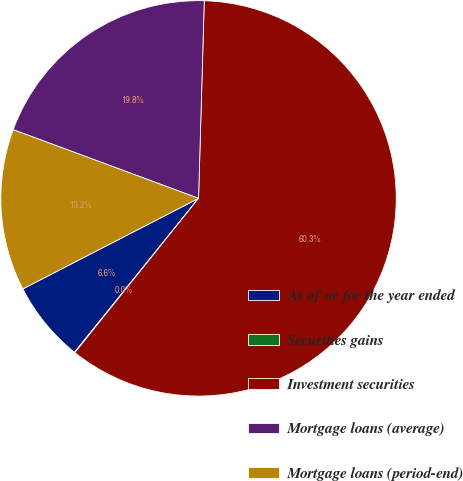Convert chart. <chart><loc_0><loc_0><loc_500><loc_500><pie_chart><fcel>As of or for the year ended<fcel>Securities gains<fcel>Investment securities<fcel>Mortgage loans (average)<fcel>Mortgage loans (period-end)<nl><fcel>6.63%<fcel>0.04%<fcel>60.29%<fcel>19.81%<fcel>13.22%<nl></chart> 